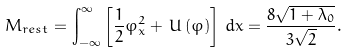<formula> <loc_0><loc_0><loc_500><loc_500>\, M _ { r e s t } = \int _ { - \infty } ^ { \infty } \left [ \frac { 1 } { 2 } \varphi _ { x } ^ { 2 } + \, U \left ( \varphi \right ) \right ] \, d x = \frac { 8 \sqrt { 1 + \lambda _ { 0 } } } { 3 \sqrt { 2 } } .</formula> 